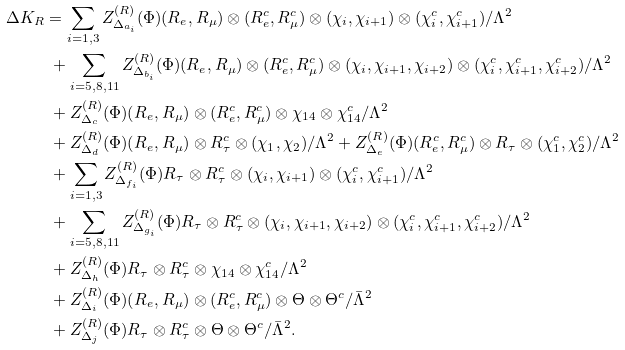Convert formula to latex. <formula><loc_0><loc_0><loc_500><loc_500>\Delta K _ { R } & = \sum _ { i = 1 , 3 } Z _ { \Delta _ { a _ { i } } } ^ { ( R ) } ( \Phi ) ( R _ { e } , R _ { \mu } ) \otimes ( R _ { e } ^ { c } , R _ { \mu } ^ { c } ) \otimes ( \chi _ { i } , \chi _ { i + 1 } ) \otimes ( \chi _ { i } ^ { c } , \chi _ { i + 1 } ^ { c } ) / \Lambda ^ { 2 } \\ & \ + \sum _ { i = 5 , 8 , 1 1 } Z _ { \Delta _ { b _ { i } } } ^ { ( R ) } ( \Phi ) ( R _ { e } , R _ { \mu } ) \otimes ( R _ { e } ^ { c } , R _ { \mu } ^ { c } ) \otimes ( \chi _ { i } , \chi _ { i + 1 } , \chi _ { i + 2 } ) \otimes ( \chi _ { i } ^ { c } , \chi _ { i + 1 } ^ { c } , \chi _ { i + 2 } ^ { c } ) / \Lambda ^ { 2 } \\ & \ + Z _ { \Delta _ { c } } ^ { ( R ) } ( \Phi ) ( R _ { e } , R _ { \mu } ) \otimes ( R _ { e } ^ { c } , R _ { \mu } ^ { c } ) \otimes \chi _ { 1 4 } \otimes \chi _ { 1 4 } ^ { c } / \Lambda ^ { 2 } \\ & \ + Z _ { \Delta _ { d } } ^ { ( R ) } ( \Phi ) ( R _ { e } , R _ { \mu } ) \otimes R _ { \tau } ^ { c } \otimes ( \chi _ { 1 } , \chi _ { 2 } ) / \Lambda ^ { 2 } + Z _ { \Delta _ { e } } ^ { ( R ) } ( \Phi ) ( R _ { e } ^ { c } , R _ { \mu } ^ { c } ) \otimes R _ { \tau } \otimes ( \chi _ { 1 } ^ { c } , \chi _ { 2 } ^ { c } ) / \Lambda ^ { 2 } \\ & \ + \sum _ { i = 1 , 3 } Z _ { \Delta _ { f _ { i } } } ^ { ( R ) } ( \Phi ) R _ { \tau } \otimes R _ { \tau } ^ { c } \otimes ( \chi _ { i } , \chi _ { i + 1 } ) \otimes ( \chi _ { i } ^ { c } , \chi _ { i + 1 } ^ { c } ) / \Lambda ^ { 2 } \\ & \ + \sum _ { i = 5 , 8 , 1 1 } Z _ { \Delta _ { g _ { i } } } ^ { ( R ) } ( \Phi ) R _ { \tau } \otimes R _ { \tau } ^ { c } \otimes ( \chi _ { i } , \chi _ { i + 1 } , \chi _ { i + 2 } ) \otimes ( \chi _ { i } ^ { c } , \chi _ { i + 1 } ^ { c } , \chi _ { i + 2 } ^ { c } ) / \Lambda ^ { 2 } \\ & \ + Z _ { \Delta _ { h } } ^ { ( R ) } ( \Phi ) R _ { \tau } \otimes R _ { \tau } ^ { c } \otimes \chi _ { 1 4 } \otimes \chi _ { 1 4 } ^ { c } / \Lambda ^ { 2 } \\ & \ + Z _ { \Delta _ { i } } ^ { ( R ) } ( \Phi ) ( R _ { e } , R _ { \mu } ) \otimes ( R _ { e } ^ { c } , R _ { \mu } ^ { c } ) \otimes \Theta \otimes \Theta ^ { c } / \bar { \Lambda } ^ { 2 } \\ & \ + Z _ { \Delta _ { j } } ^ { ( R ) } ( \Phi ) R _ { \tau } \otimes R _ { \tau } ^ { c } \otimes \Theta \otimes \Theta ^ { c } / \bar { \Lambda } ^ { 2 } .</formula> 